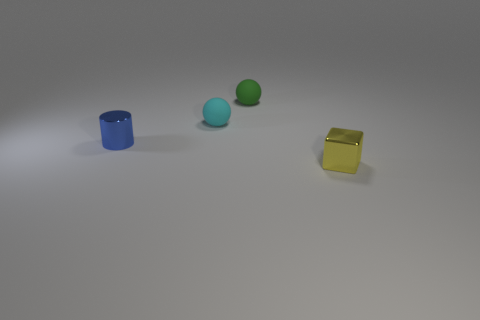Add 1 tiny green matte cylinders. How many objects exist? 5 Subtract all cylinders. How many objects are left? 3 Subtract all small blue objects. Subtract all small yellow metal objects. How many objects are left? 2 Add 2 small yellow shiny things. How many small yellow shiny things are left? 3 Add 2 large purple rubber balls. How many large purple rubber balls exist? 2 Subtract 0 red blocks. How many objects are left? 4 